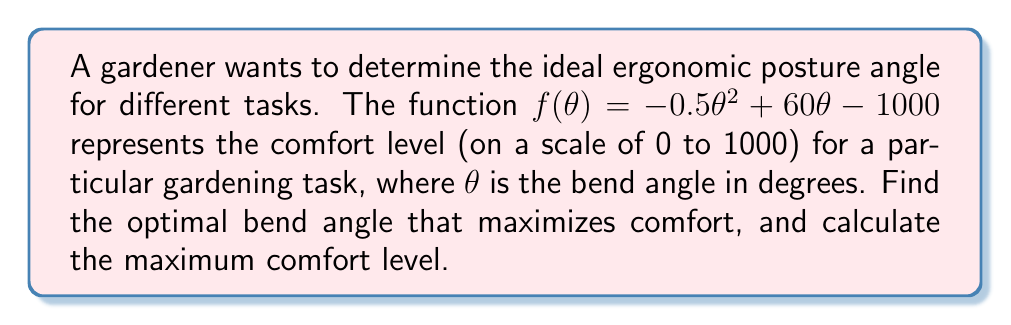What is the answer to this math problem? 1) To find the optimal bend angle, we need to find the maximum of the function $f(\theta)$. This occurs at the vertex of the parabola.

2) For a quadratic function in the form $f(\theta) = a\theta^2 + b\theta + c$, the vertex occurs at $\theta = -\frac{b}{2a}$.

3) In our function $f(\theta) = -0.5\theta^2 + 60\theta - 1000$, we have:
   $a = -0.5$
   $b = 60$
   $c = -1000$

4) Calculating the optimal angle:
   $$\theta_{optimal} = -\frac{b}{2a} = -\frac{60}{2(-0.5)} = \frac{60}{1} = 60^\circ$$

5) To find the maximum comfort level, we substitute this optimal angle back into the original function:

   $$f(60) = -0.5(60)^2 + 60(60) - 1000$$
   $$= -0.5(3600) + 3600 - 1000$$
   $$= -1800 + 3600 - 1000$$
   $$= 800$$

6) Therefore, the maximum comfort level is 800 out of 1000.
Answer: Optimal bend angle: $60^\circ$; Maximum comfort level: 800 